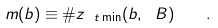<formula> <loc_0><loc_0><loc_500><loc_500>m ( b ) \equiv \# z _ { \ t \min } ( b , \ B ) \quad .</formula> 